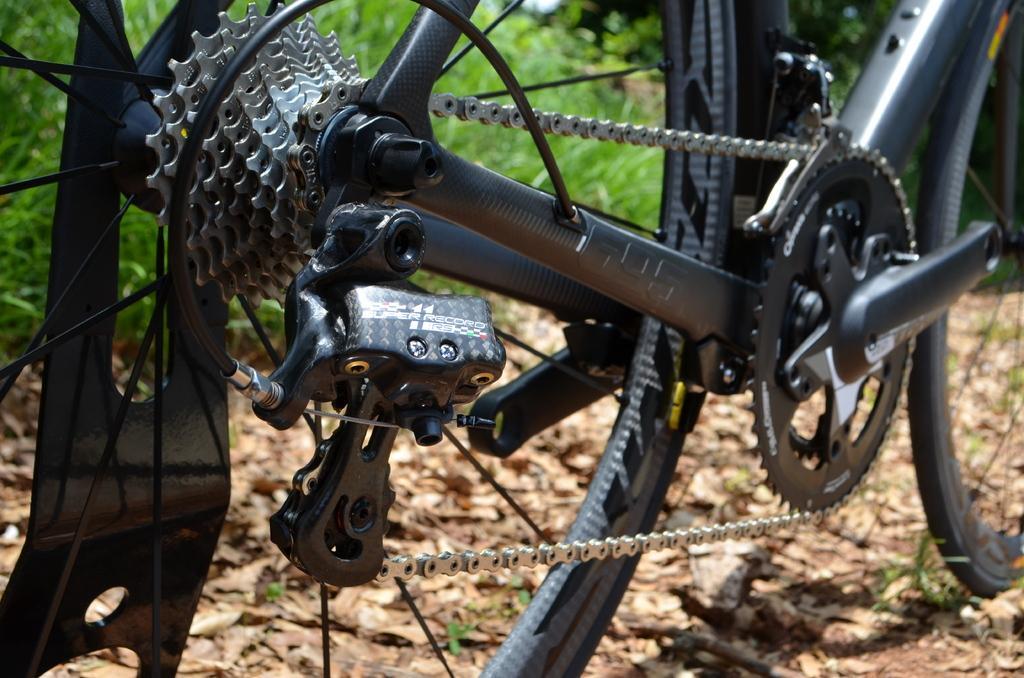Describe this image in one or two sentences. In this image I see a cycle over here which is of black in color and I see ground on which there are leaves. In the background I see the grass. 